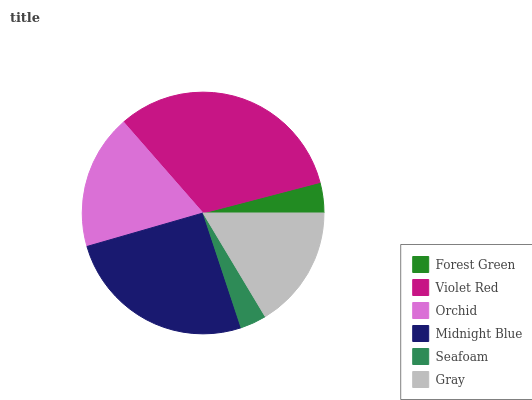Is Seafoam the minimum?
Answer yes or no. Yes. Is Violet Red the maximum?
Answer yes or no. Yes. Is Orchid the minimum?
Answer yes or no. No. Is Orchid the maximum?
Answer yes or no. No. Is Violet Red greater than Orchid?
Answer yes or no. Yes. Is Orchid less than Violet Red?
Answer yes or no. Yes. Is Orchid greater than Violet Red?
Answer yes or no. No. Is Violet Red less than Orchid?
Answer yes or no. No. Is Orchid the high median?
Answer yes or no. Yes. Is Gray the low median?
Answer yes or no. Yes. Is Midnight Blue the high median?
Answer yes or no. No. Is Seafoam the low median?
Answer yes or no. No. 